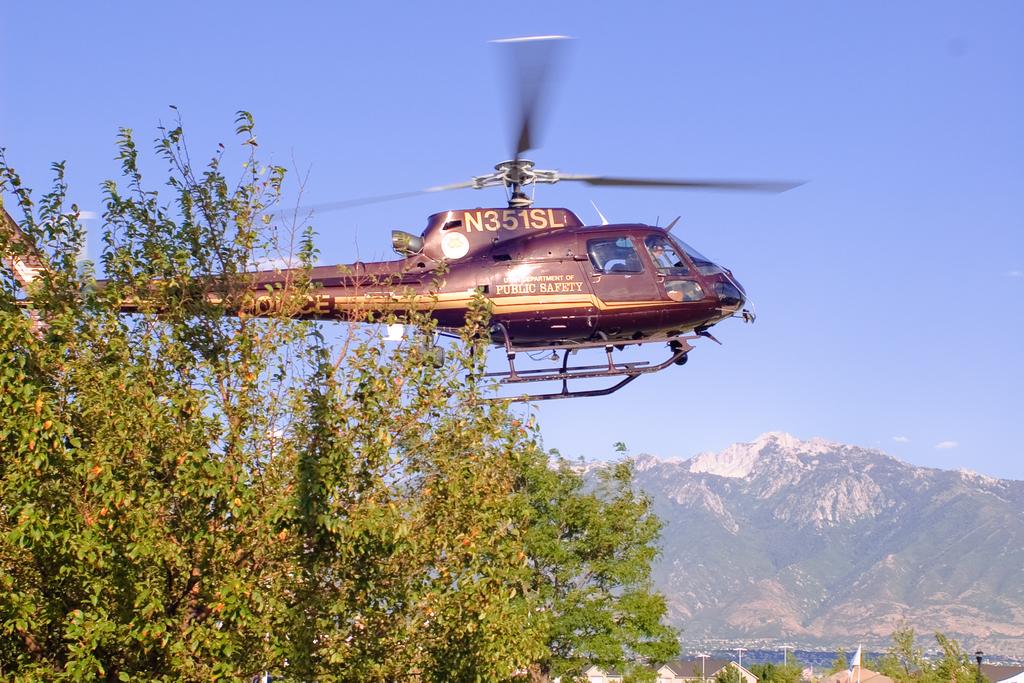To which organization does this helicopter belong?
Your response must be concise. Public safety. 